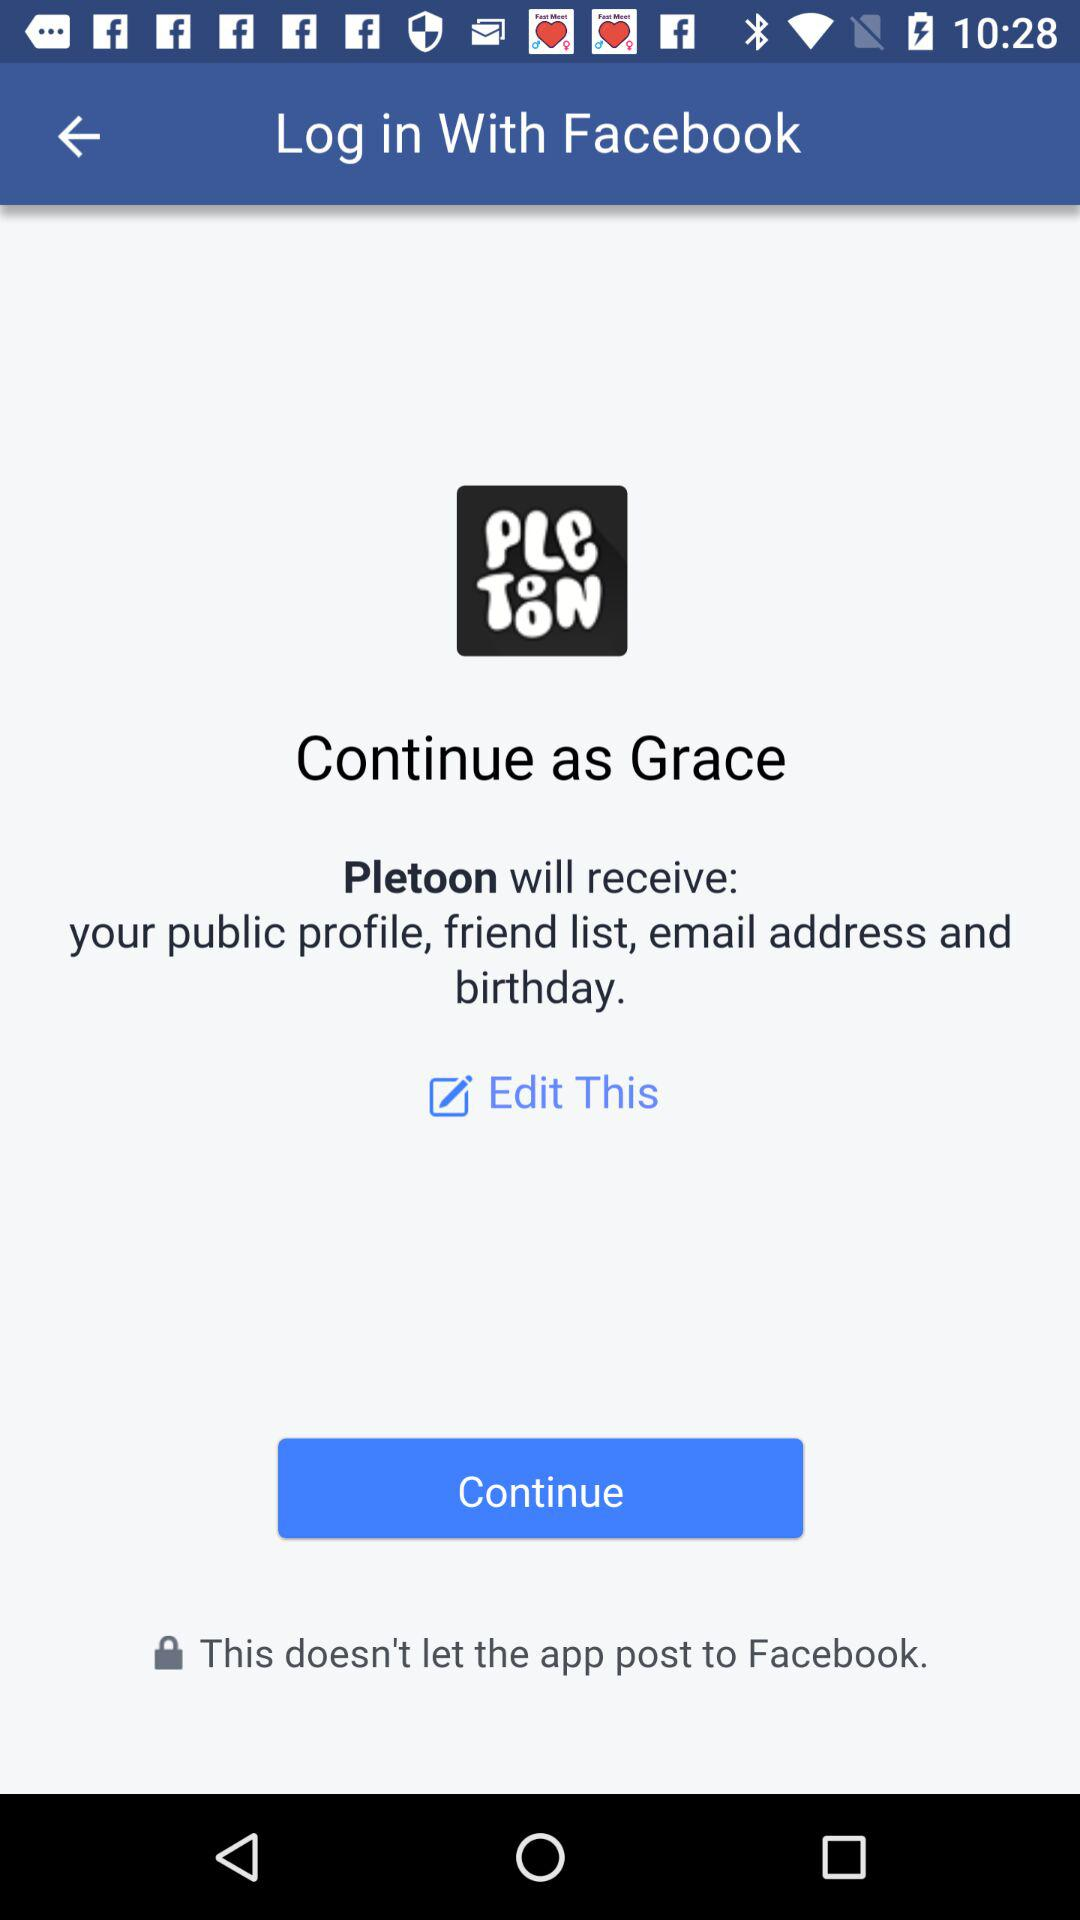What application can be used to log in to a profile? The application that can be used to log in to a profile is Facebook. 